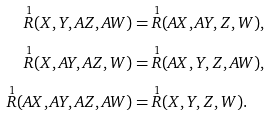Convert formula to latex. <formula><loc_0><loc_0><loc_500><loc_500>\overset { 1 } { R } ( X , Y , A Z , A W ) & = \overset { 1 } { R } ( A X , A Y , Z , W ) , \\ \overset { 1 } { R } ( X , A Y , A Z , W ) & = \overset { 1 } { R } ( A X , Y , Z , A W ) , \\ \overset { 1 } { R } ( A X , A Y , A Z , A W ) & = \overset { 1 } { R } ( X , Y , Z , W ) .</formula> 